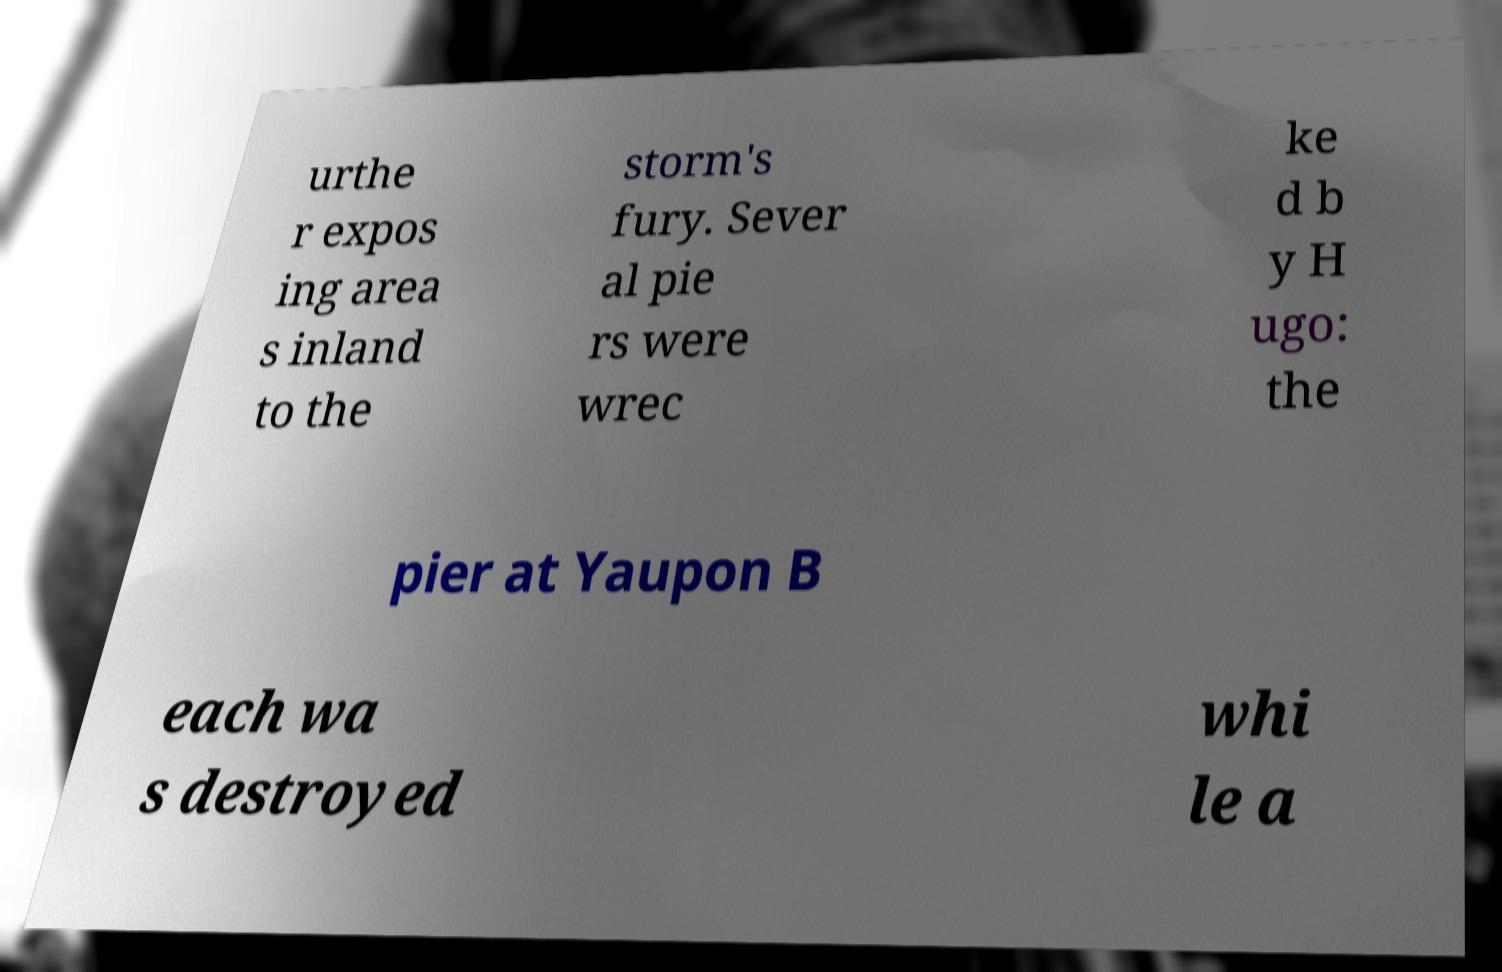There's text embedded in this image that I need extracted. Can you transcribe it verbatim? urthe r expos ing area s inland to the storm's fury. Sever al pie rs were wrec ke d b y H ugo: the pier at Yaupon B each wa s destroyed whi le a 